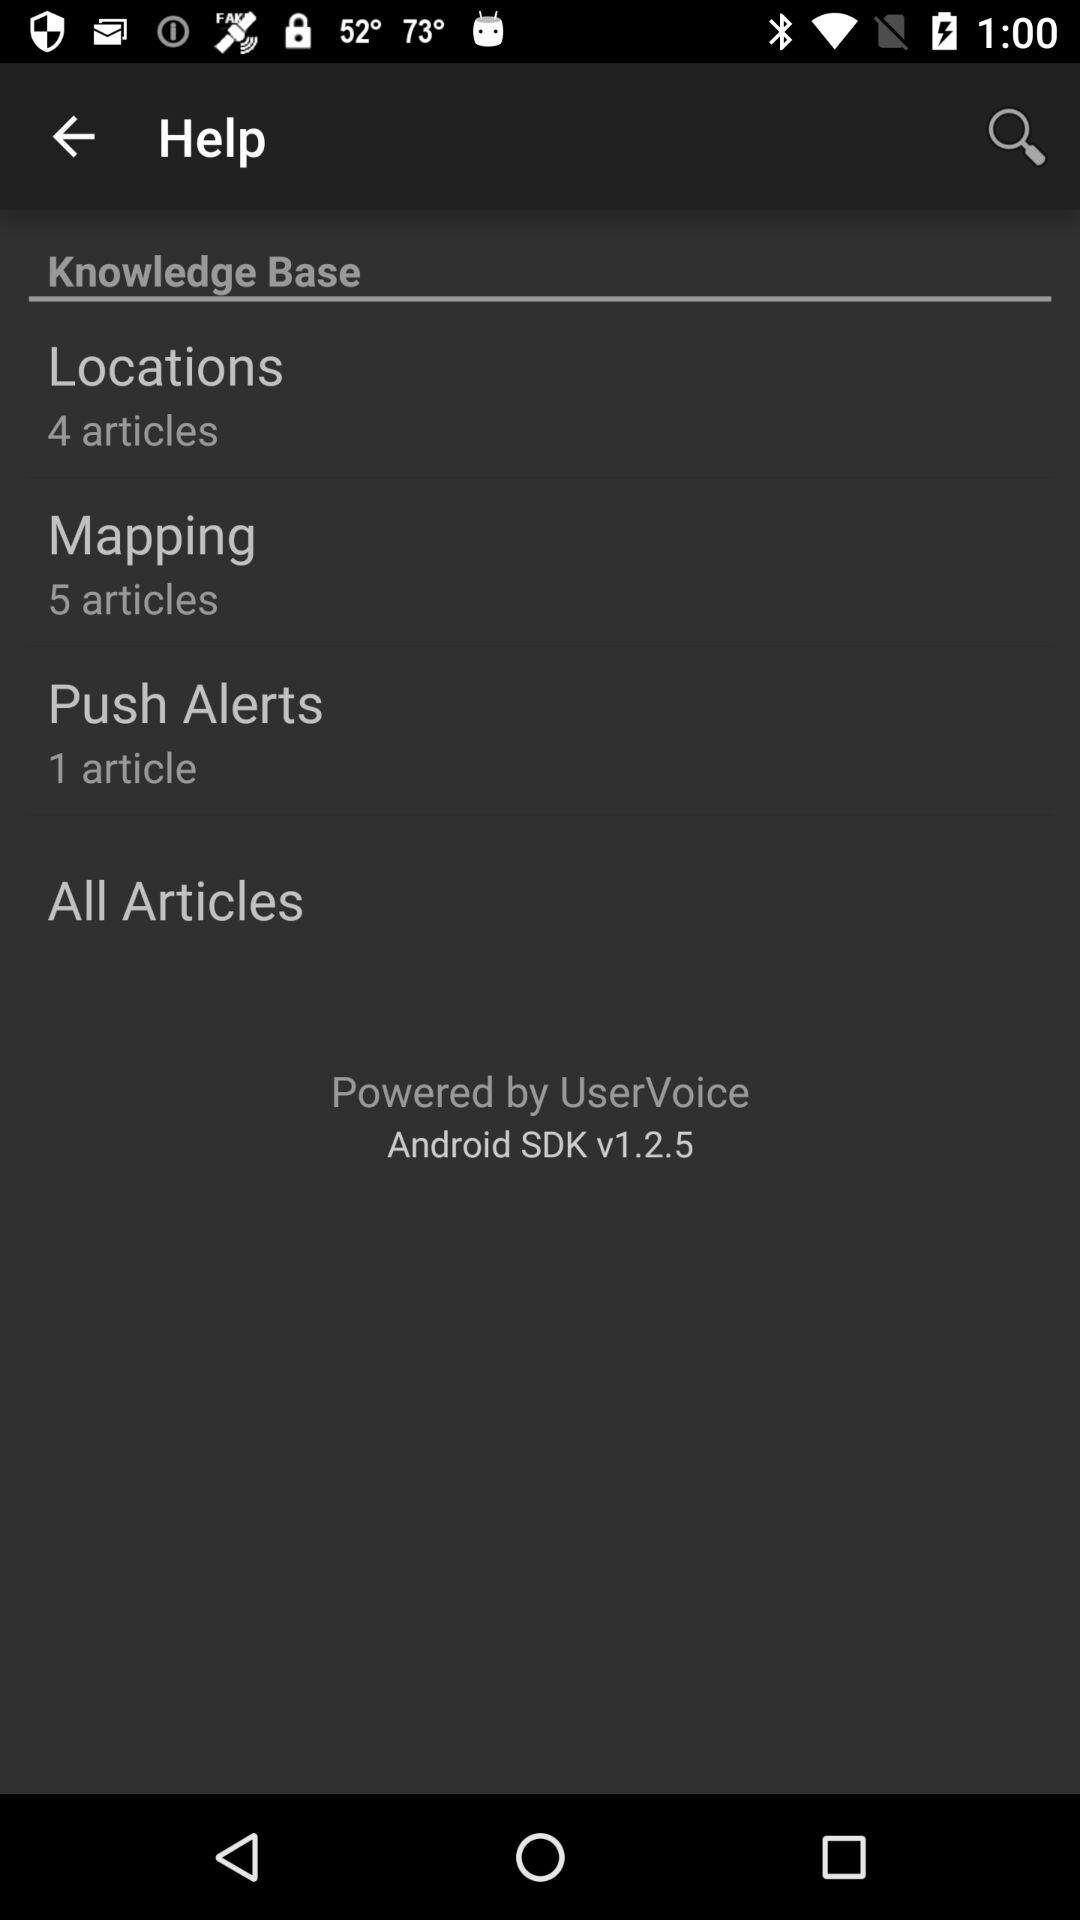How many articles are there for "Mapping"? There are 5 articles. 